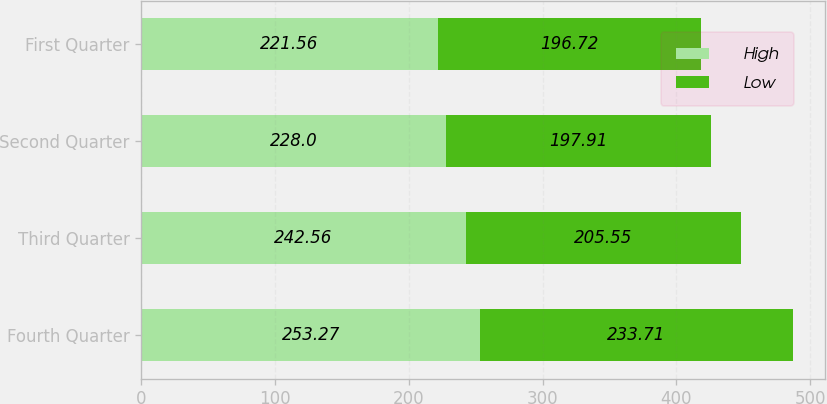Convert chart. <chart><loc_0><loc_0><loc_500><loc_500><stacked_bar_chart><ecel><fcel>Fourth Quarter<fcel>Third Quarter<fcel>Second Quarter<fcel>First Quarter<nl><fcel>High<fcel>253.27<fcel>242.56<fcel>228<fcel>221.56<nl><fcel>Low<fcel>233.71<fcel>205.55<fcel>197.91<fcel>196.72<nl></chart> 